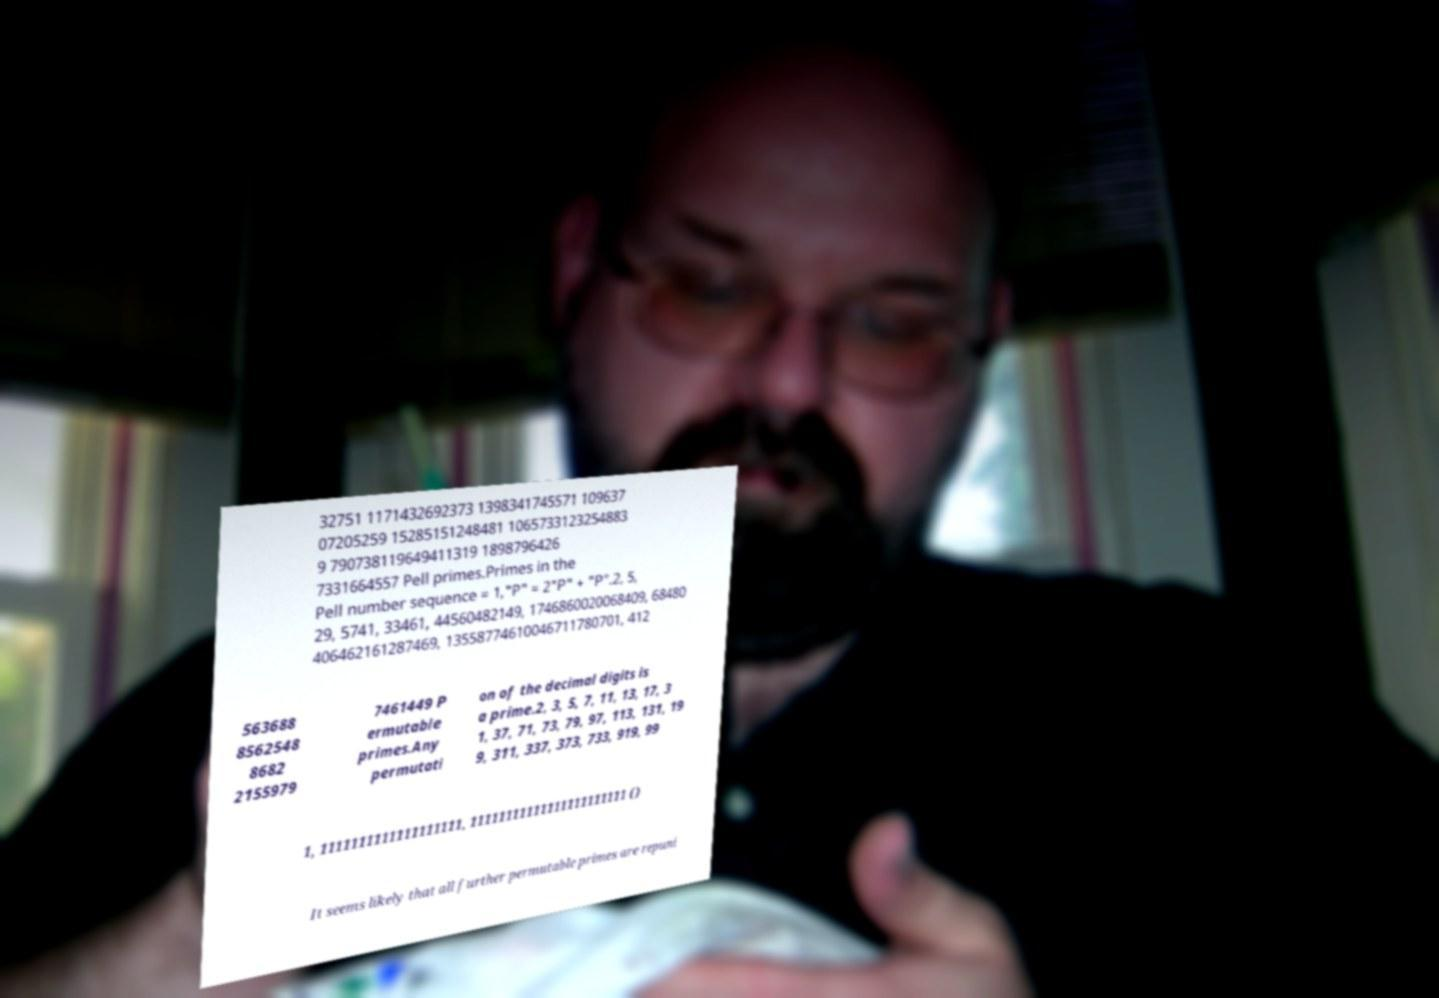For documentation purposes, I need the text within this image transcribed. Could you provide that? 32751 1171432692373 1398341745571 109637 07205259 15285151248481 1065733123254883 9 790738119649411319 1898796426 7331664557 Pell primes.Primes in the Pell number sequence = 1,"P" = 2"P" + "P".2, 5, 29, 5741, 33461, 44560482149, 1746860020068409, 68480 406462161287469, 13558774610046711780701, 412 563688 8562548 8682 2155979 7461449 P ermutable primes.Any permutati on of the decimal digits is a prime.2, 3, 5, 7, 11, 13, 17, 3 1, 37, 71, 73, 79, 97, 113, 131, 19 9, 311, 337, 373, 733, 919, 99 1, 1111111111111111111, 11111111111111111111111 () It seems likely that all further permutable primes are repuni 